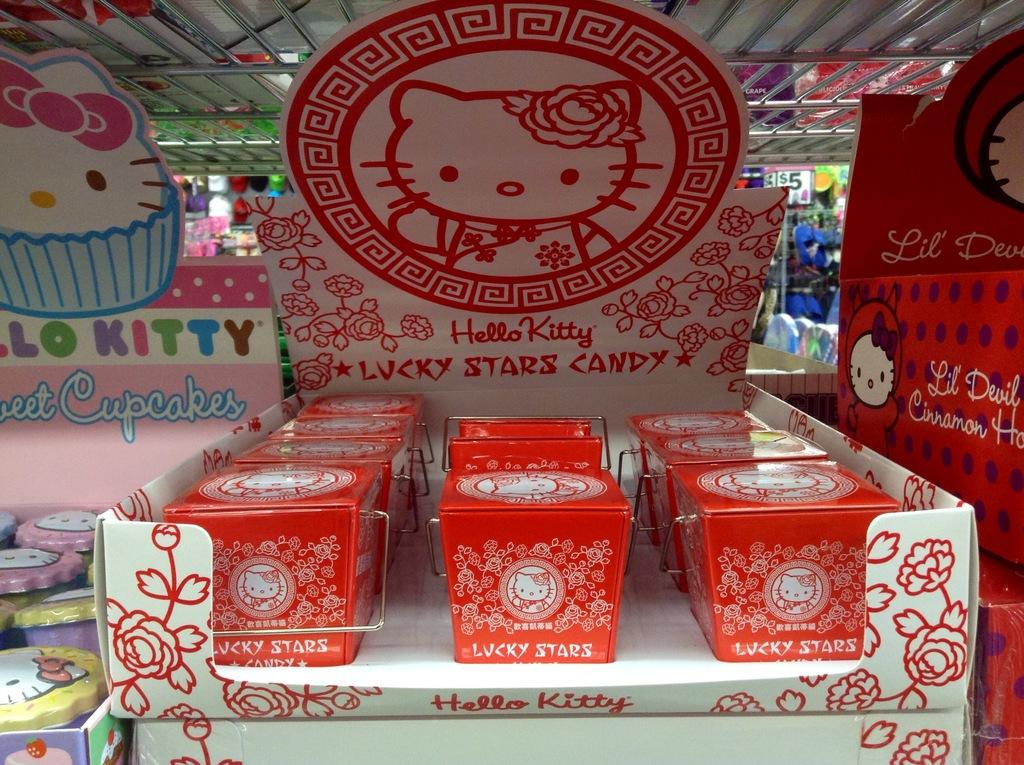<image>
Summarize the visual content of the image. A display of Lucky Stars Candy sits atop a shelf. 